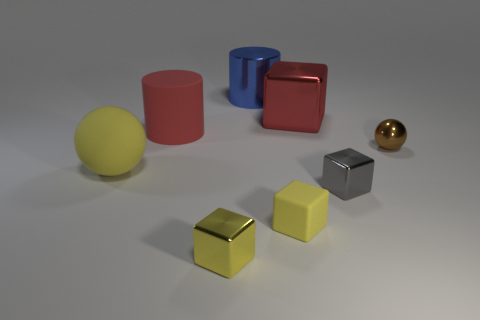Subtract all purple blocks. Subtract all gray balls. How many blocks are left? 4 Add 1 green cylinders. How many objects exist? 9 Subtract all cylinders. How many objects are left? 6 Add 2 gray cubes. How many gray cubes are left? 3 Add 8 big red rubber cylinders. How many big red rubber cylinders exist? 9 Subtract 0 blue blocks. How many objects are left? 8 Subtract all yellow things. Subtract all big yellow cylinders. How many objects are left? 5 